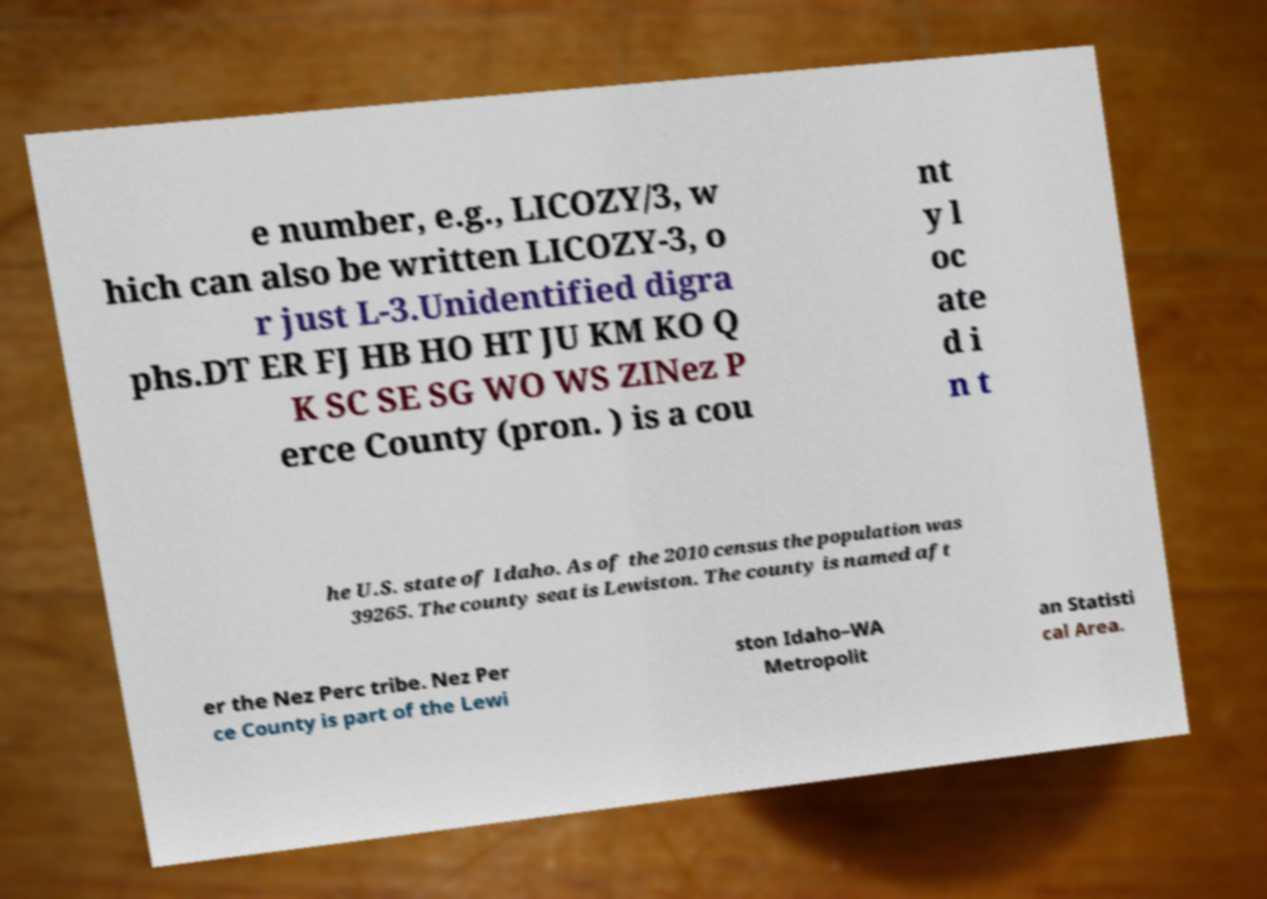What messages or text are displayed in this image? I need them in a readable, typed format. e number, e.g., LICOZY/3, w hich can also be written LICOZY-3, o r just L-3.Unidentified digra phs.DT ER FJ HB HO HT JU KM KO Q K SC SE SG WO WS ZINez P erce County (pron. ) is a cou nt y l oc ate d i n t he U.S. state of Idaho. As of the 2010 census the population was 39265. The county seat is Lewiston. The county is named aft er the Nez Perc tribe. Nez Per ce County is part of the Lewi ston Idaho–WA Metropolit an Statisti cal Area. 